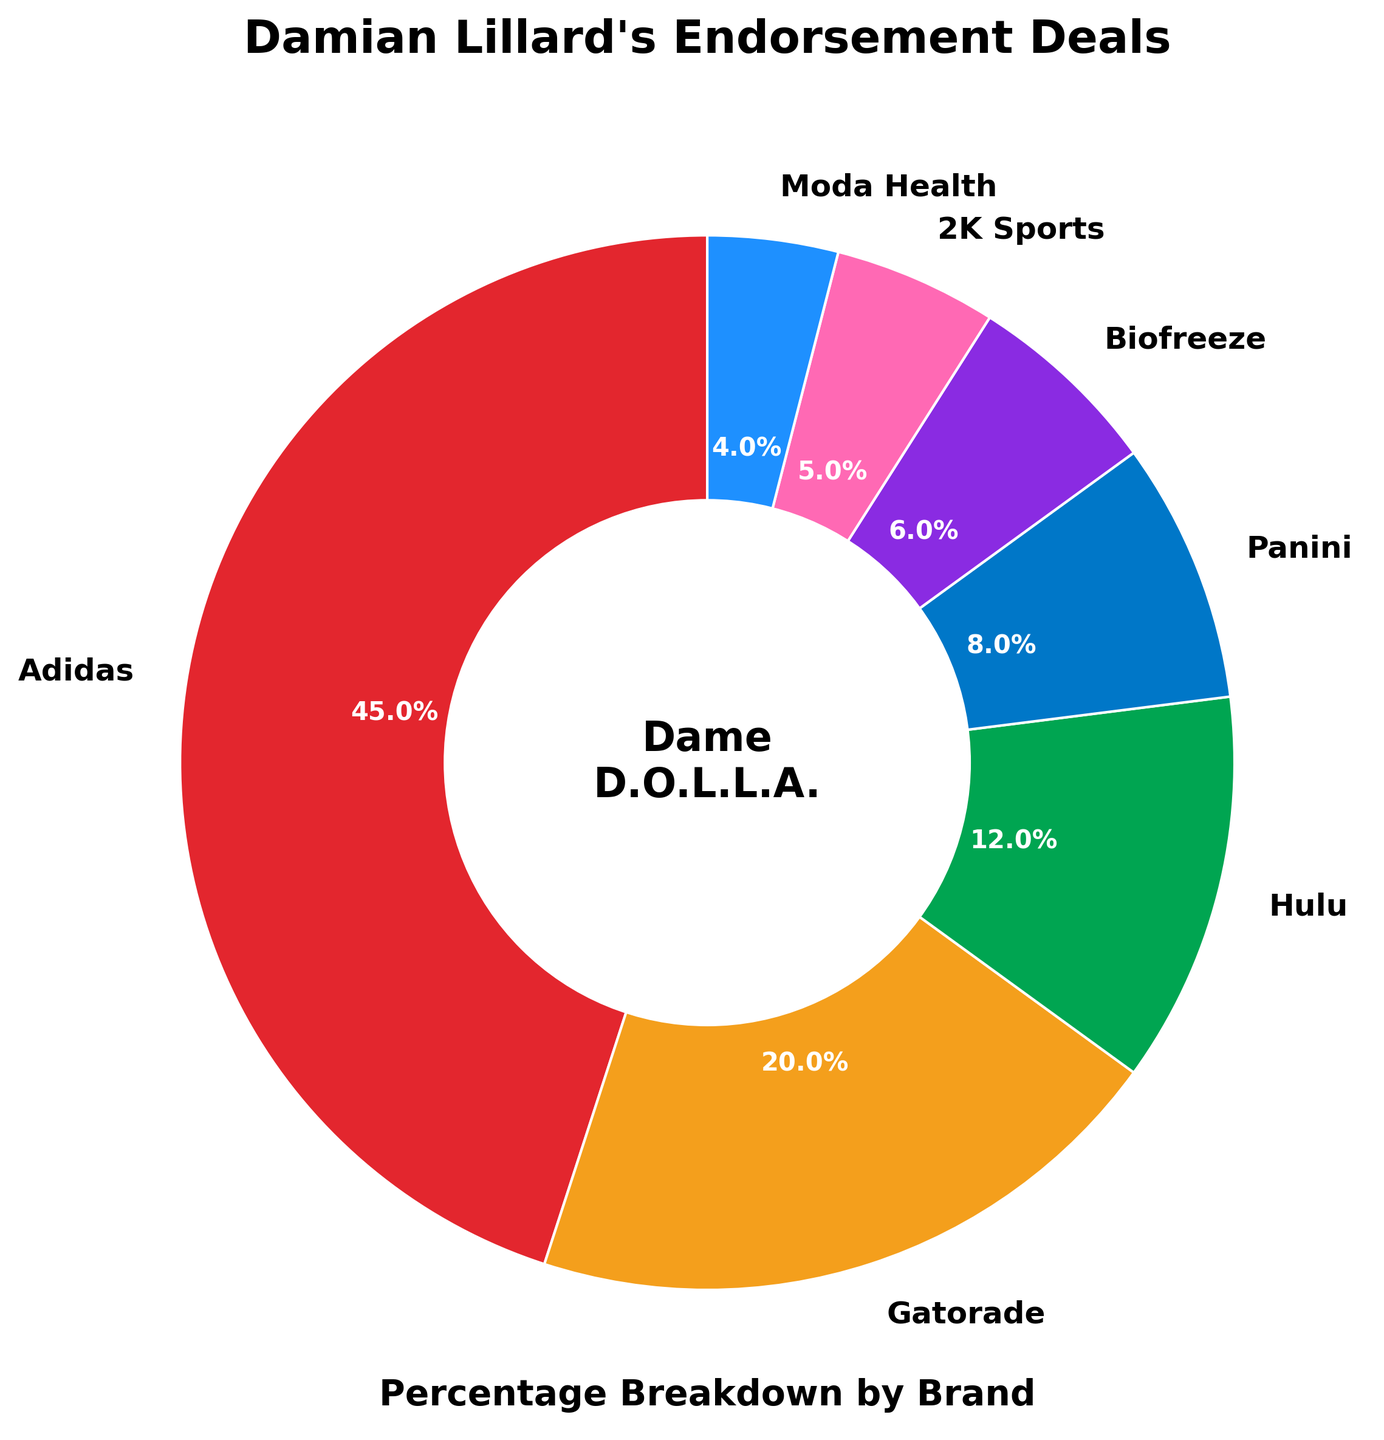What's the largest endorsement deal brand by percentage? The pie chart shows the percentage breakdown by brand, where the largest segment represents the largest endorsement deal. The brand with the largest percentage is shown within the largest segment.
Answer: Adidas Which brands have a combined percentage greater than 50%? To find the combined percentage greater than 50%, we look for the top brands and add their percentages until the sum exceeds 50%. Adidas (45%) + Gatorade (20%) = 65%, which is greater than 50%.
Answer: Adidas and Gatorade What is the smallest endorsement deal percentage, and which brand does it belong to? The pie chart shows each brand’s percentage, and the smallest segment represents the smallest percentage. This segment is labeled on the pie chart.
Answer: Moda Health How much greater is Adidas's percentage than Biofreeze's percentage? Subtract Biofreeze's percentage (6%) from Adidas's percentage (45%) to determine how much greater it is.
Answer: 39% Which brand's segment is represented by a pink segment? Examine the pink segment in the pie chart, note the brand label associated with that color.
Answer: 2K Sports What is the total percentage of deals represented by Hulu and Panini combined? Add Hulu's percentage (12%) and Panini's percentage (8%), so 12% + 8% = 20%.
Answer: 20% If Moda Health's percentage doubled, would it be greater than Gatorade's percentage? Double Moda Health's 4% to get 8%. Then compare it to Gatorade's percentage (20%). Since 8% is less than 20%, Moda Health's doubled percentage would not surpass Gatorade's.
Answer: No What is the difference between the percentages of Gatorade and Hulu? Subtract Hulu's percentage (12%) from Gatorade's percentage (20%). The difference is 20% - 12% = 8%.
Answer: 8% Which two brands combined have an endorsement deal percentage of less than 10%? Look for two brands whose percentages sum to less than 10%. Moda Health (4%) and 2K Sports (5%), combined, make 4% + 5% = 9%, which is less than 10%.
Answer: Moda Health and 2K Sports 